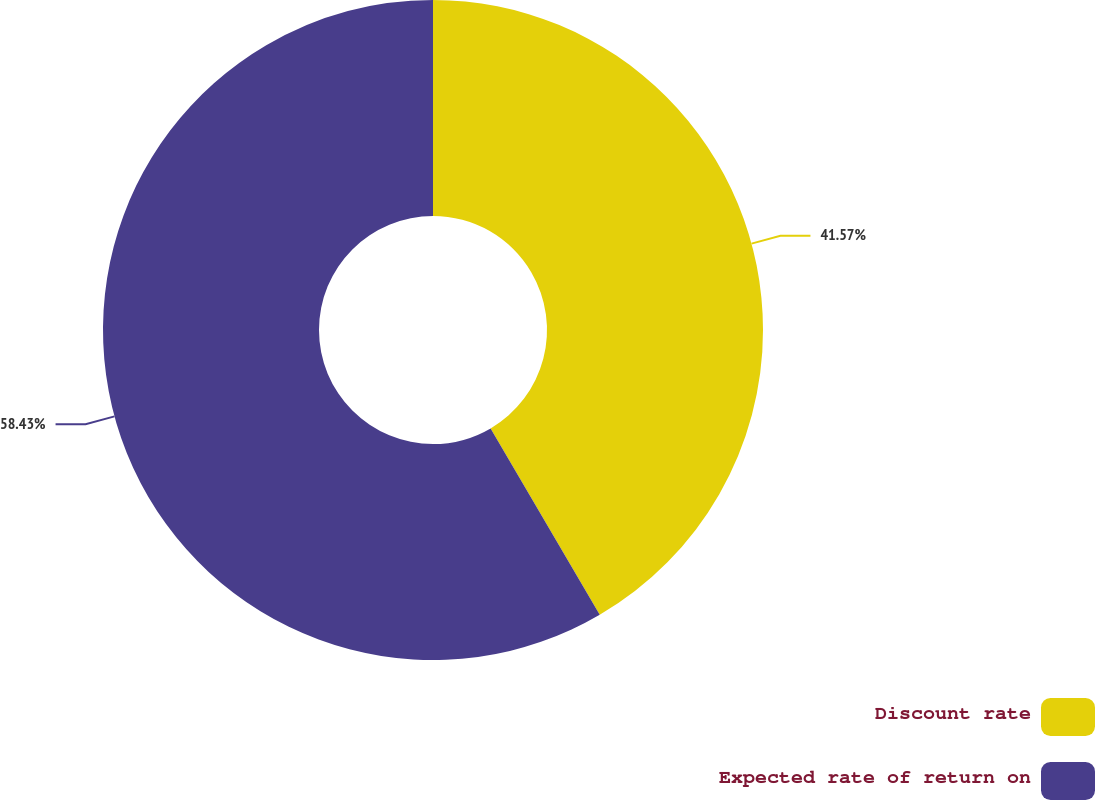<chart> <loc_0><loc_0><loc_500><loc_500><pie_chart><fcel>Discount rate<fcel>Expected rate of return on<nl><fcel>41.57%<fcel>58.43%<nl></chart> 